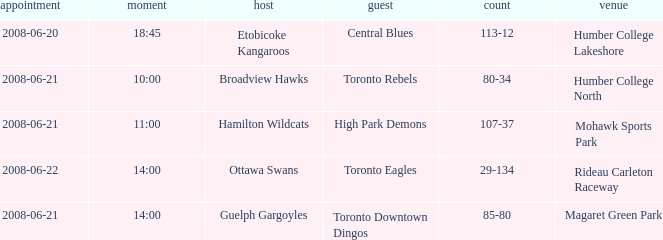What is the Ground with a Date that is 2008-06-20? Humber College Lakeshore. 